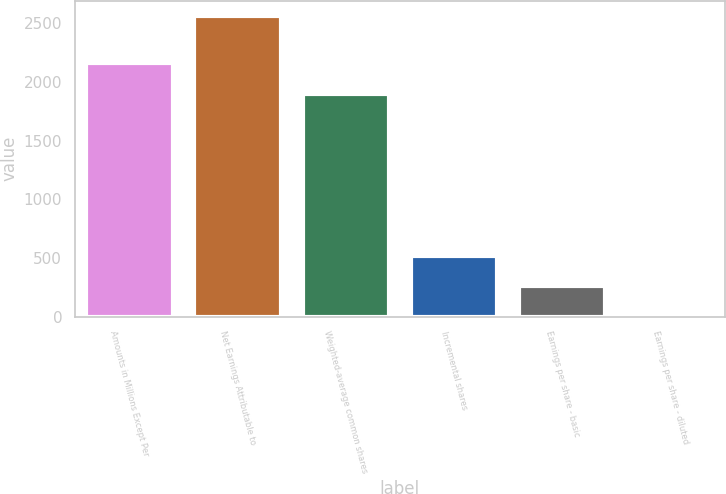Convert chart. <chart><loc_0><loc_0><loc_500><loc_500><bar_chart><fcel>Amounts in Millions Except Per<fcel>Net Earnings Attributable to<fcel>Weighted-average common shares<fcel>Incremental shares<fcel>Earnings per share - basic<fcel>Earnings per share - diluted<nl><fcel>2156.3<fcel>2563<fcel>1900.15<fcel>513.84<fcel>257.69<fcel>1.54<nl></chart> 